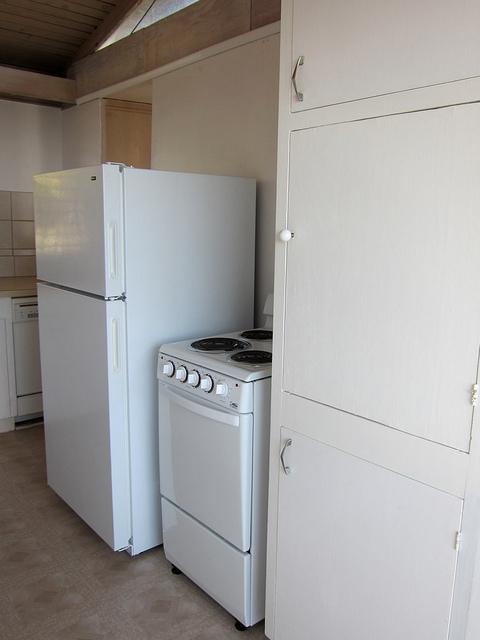What material is covering the floor?
Concise answer only. Tile. Does the refrigerator open to the left or the right?
Be succinct. Left. Are these appliance new?
Concise answer only. Yes. What color are the appliances?
Answer briefly. White. Does the fridge have the same height as the oven?
Concise answer only. No. 